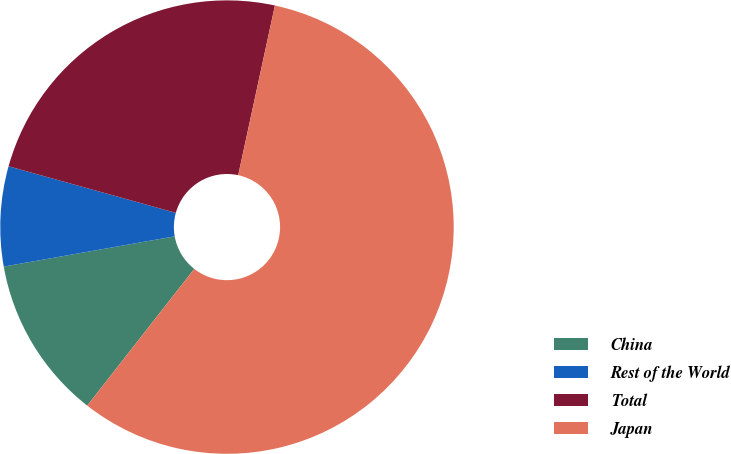<chart> <loc_0><loc_0><loc_500><loc_500><pie_chart><fcel>China<fcel>Rest of the World<fcel>Total<fcel>Japan<nl><fcel>11.64%<fcel>7.11%<fcel>24.07%<fcel>57.18%<nl></chart> 